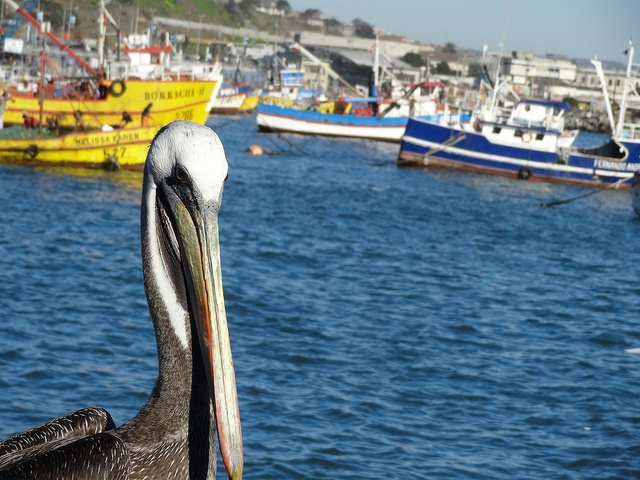Describe the objects in this image and their specific colors. I can see bird in gray, black, ivory, and darkgray tones, boat in gray, white, darkblue, and darkgray tones, boat in gray, gold, brown, and orange tones, boat in gray, gold, and olive tones, and boat in gray, white, and darkgray tones in this image. 